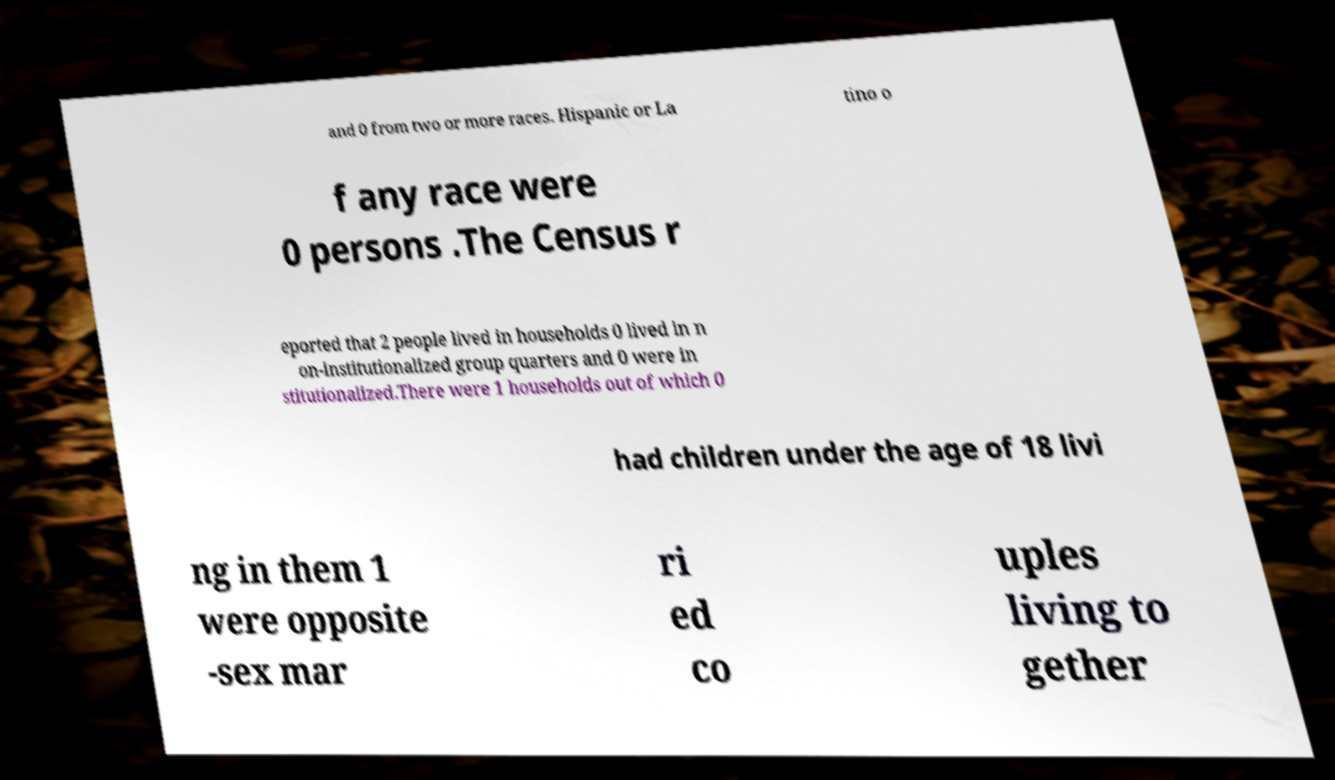Can you read and provide the text displayed in the image?This photo seems to have some interesting text. Can you extract and type it out for me? and 0 from two or more races. Hispanic or La tino o f any race were 0 persons .The Census r eported that 2 people lived in households 0 lived in n on-institutionalized group quarters and 0 were in stitutionalized.There were 1 households out of which 0 had children under the age of 18 livi ng in them 1 were opposite -sex mar ri ed co uples living to gether 